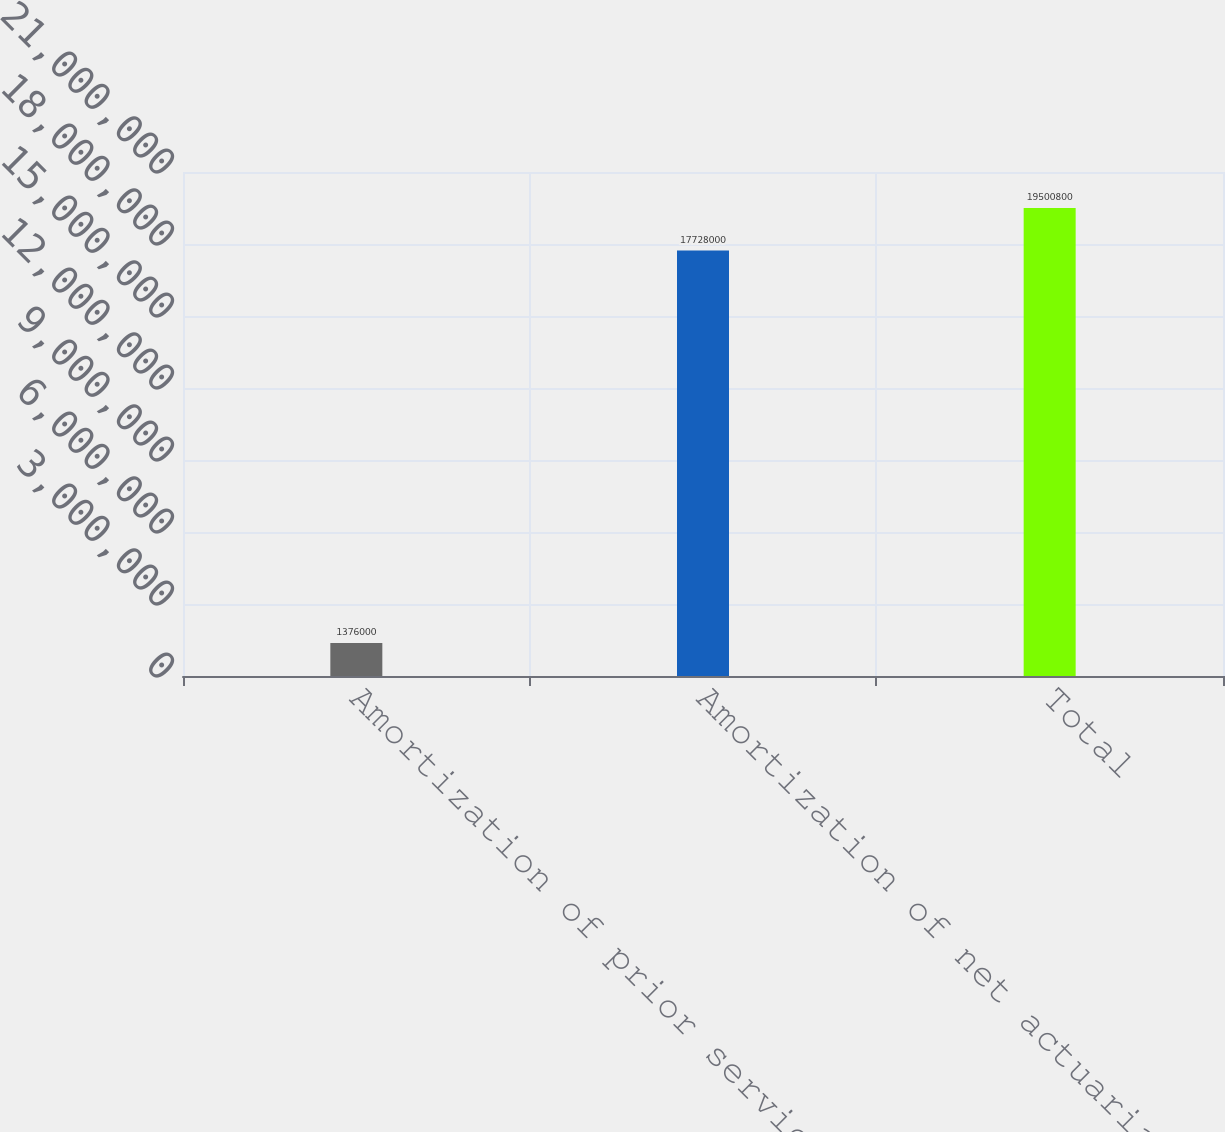<chart> <loc_0><loc_0><loc_500><loc_500><bar_chart><fcel>Amortization of prior service<fcel>Amortization of net actuarial<fcel>Total<nl><fcel>1.376e+06<fcel>1.7728e+07<fcel>1.95008e+07<nl></chart> 